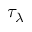<formula> <loc_0><loc_0><loc_500><loc_500>\tau _ { \lambda }</formula> 